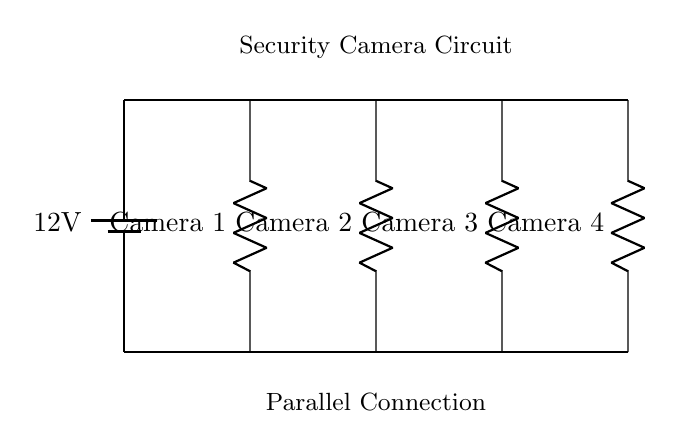What is the total number of security cameras in this circuit? The circuit diagram explicitly shows four separate components labeled as "Camera 1," "Camera 2," "Camera 3," and "Camera 4." Thus, by counting these labels, we find that there are a total of four security cameras.
Answer: Four What is the voltage supplied to the cameras? The circuit diagram indicates a power supply labeled as a "12V" battery. This is the voltage provided to the entire circuit, ensuring all cameras operate at the same voltage level.
Answer: Twelve volts How are the cameras connected in this circuit? The diagram shows that the cameras are connected in parallel, which means each camera has its own direct connection to the power supply while also sharing the same voltage. This is indicated by the individual connections from the main line to each camera.
Answer: Parallel How does the total current compare to the current through each camera? In a parallel circuit, the total current is the sum of the currents through each individual branch (camera). This means that if one camera draws a certain amount of current, the total current drawn from the power source is the sum of the currents from all cameras.
Answer: Total current is higher What would happen if one camera fails in this circuit? Since the cameras are arranged in a parallel connection, if one camera fails (becomes an open circuit), the other cameras will continue to function normally as they still have their own path to the power supply. This is a key characteristic of parallel circuits, enhancing reliability.
Answer: Others continue functioning What is the role of the battery in this circuit? The battery provides the necessary voltage to power the security cameras. Without it, the cameras would not operate. The battery ensures that all components receive the same voltage required for their operation.
Answer: Power supply 